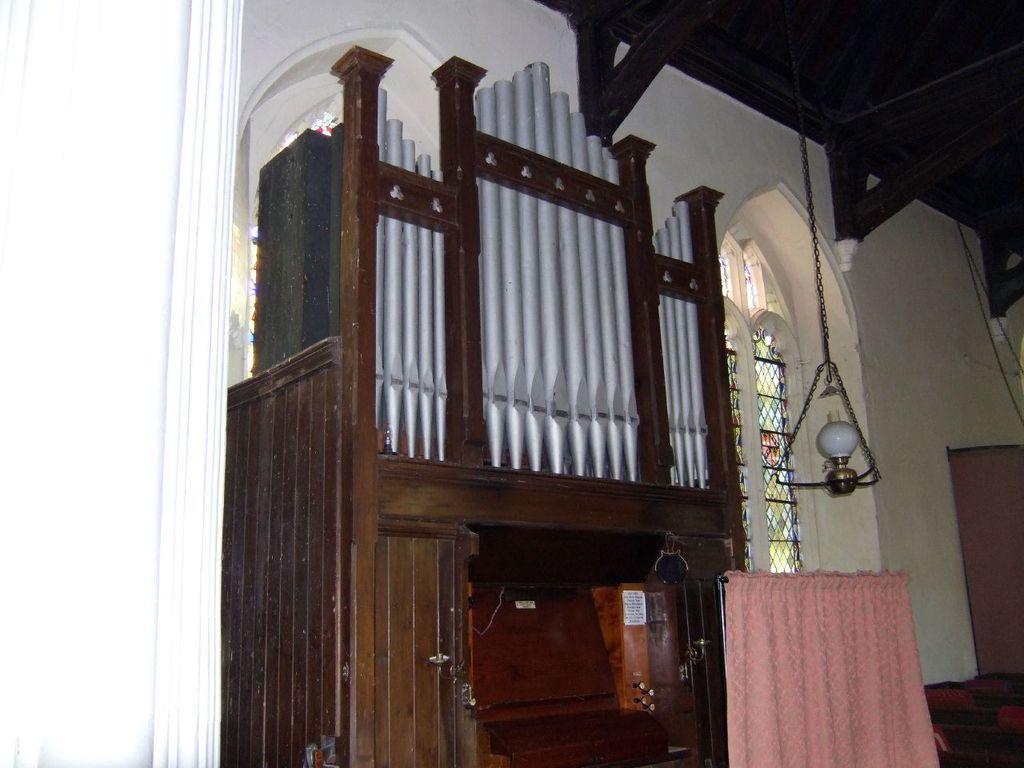Describe this image in one or two sentences. Here in this picture we can see a wooden cup board present over there and beside it we can see a window and a curtain present and we can see a light is hanging on the roof over there. 